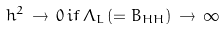<formula> <loc_0><loc_0><loc_500><loc_500>h ^ { 2 } \, \rightarrow \, 0 \, i f \, \Lambda _ { L } \, ( = B _ { H H } ) \, \rightarrow \, \infty</formula> 